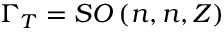Convert formula to latex. <formula><loc_0><loc_0><loc_500><loc_500>\Gamma _ { T } = S O \left ( n , n , Z \right )</formula> 